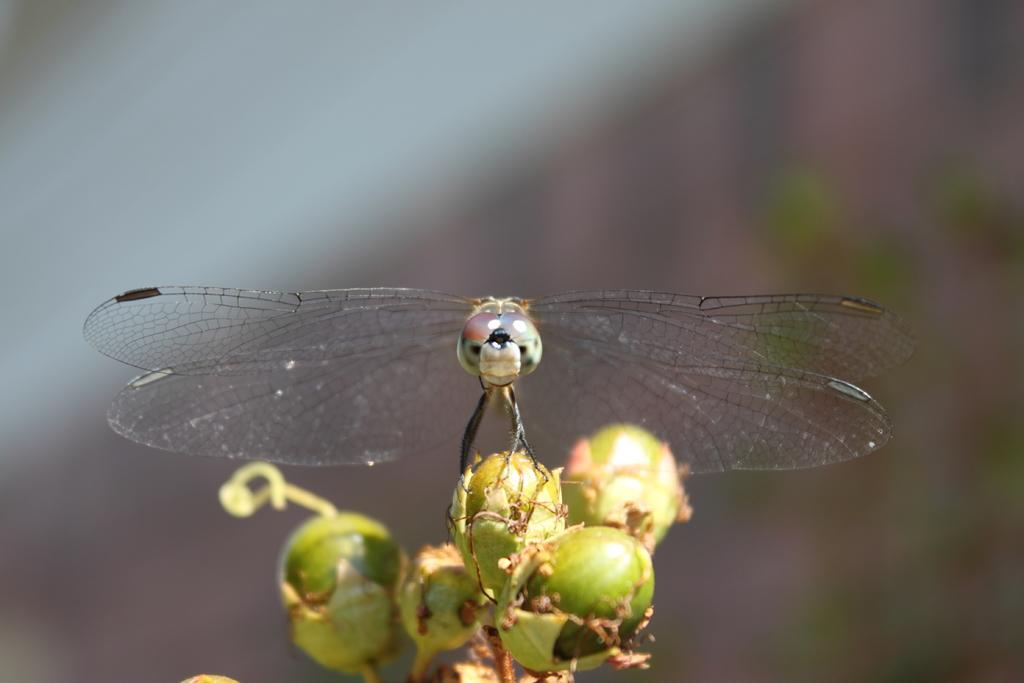What is the main subject of the image? There is a dragonfly in the image. Where is the dragonfly located in the image? The dragonfly is on buds. Can you describe the background of the image? The background of the image is blurred. What is the dragonfly's tendency to attempt eating tomatoes in the image? There are no tomatoes present in the image, and therefore no such activity or tendency can be observed. 